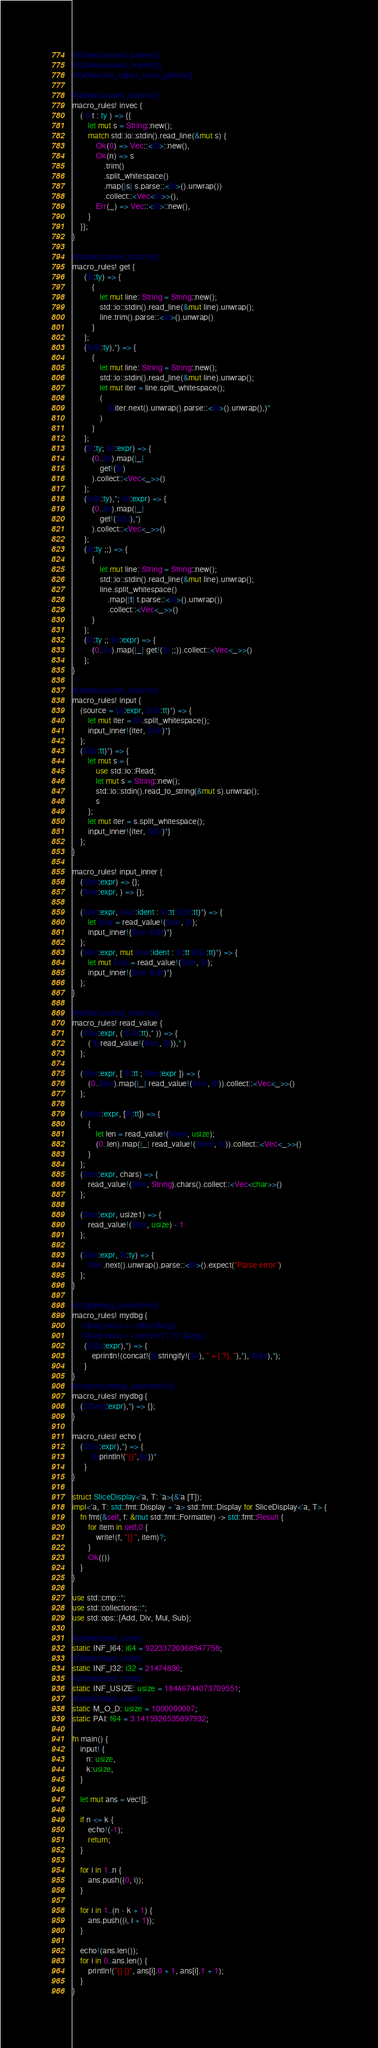Convert code to text. <code><loc_0><loc_0><loc_500><loc_500><_Rust_>#![allow(unused_parens)]
#![allow(unused_imports)]
#![allow(non_upper_case_globals)]

#[allow(unused_macros)]
macro_rules! invec {
    ( $ t : ty ) => {{
        let mut s = String::new();
        match std::io::stdin().read_line(&mut s) {
            Ok(0) => Vec::<$t>::new(),
            Ok(n) => s
                .trim()
                .split_whitespace()
                .map(|s| s.parse::<$t>().unwrap())
                .collect::<Vec<$t>>(),
            Err(_) => Vec::<$t>::new(),
        }
    }};
}

#[allow(unused_macros)]
macro_rules! get {
      ($t:ty) => {
          {
              let mut line: String = String::new();
              std::io::stdin().read_line(&mut line).unwrap();
              line.trim().parse::<$t>().unwrap()
          }
      };
      ($($t:ty),*) => {
          {
              let mut line: String = String::new();
              std::io::stdin().read_line(&mut line).unwrap();
              let mut iter = line.split_whitespace();
              (
                  $(iter.next().unwrap().parse::<$t>().unwrap(),)*
              )
          }
      };
      ($t:ty; $n:expr) => {
          (0..$n).map(|_|
              get!($t)
          ).collect::<Vec<_>>()
      };
      ($($t:ty),*; $n:expr) => {
          (0..$n).map(|_|
              get!($($t),*)
          ).collect::<Vec<_>>()
      };
      ($t:ty ;;) => {
          {
              let mut line: String = String::new();
              std::io::stdin().read_line(&mut line).unwrap();
              line.split_whitespace()
                  .map(|t| t.parse::<$t>().unwrap())
                  .collect::<Vec<_>>()
          }
      };
      ($t:ty ;; $n:expr) => {
          (0..$n).map(|_| get!($t ;;)).collect::<Vec<_>>()
      };
}

#[allow(unused_macros)]
macro_rules! input {
    (source = $s:expr, $($r:tt)*) => {
        let mut iter = $s.split_whitespace();
        input_inner!{iter, $($r)*}
    };
    ($($r:tt)*) => {
        let mut s = {
            use std::io::Read;
            let mut s = String::new();
            std::io::stdin().read_to_string(&mut s).unwrap();
            s
        };
        let mut iter = s.split_whitespace();
        input_inner!{iter, $($r)*}
    };
}

macro_rules! input_inner {
    ($iter:expr) => {};
    ($iter:expr, ) => {};

    ($iter:expr, $var:ident : $t:tt $($r:tt)*) => {
        let $var = read_value!($iter, $t);
        input_inner!{$iter $($r)*}
    };
    ($iter:expr, mut $var:ident : $t:tt $($r:tt)*) => {
        let mut $var = read_value!($iter, $t);
        input_inner!{$iter $($r)*}
    };
}

#[allow(unused_macros)]
macro_rules! read_value {
    ($iter:expr, ( $($t:tt),* )) => {
        ( $(read_value!($iter, $t)),* )
    };

    ($iter:expr, [ $t:tt ; $len:expr ]) => {
        (0..$len).map(|_| read_value!($iter, $t)).collect::<Vec<_>>()
    };

    ($next:expr, [$t:tt]) => {
        {
            let len = read_value!($next, usize);
            (0..len).map(|_| read_value!($next, $t)).collect::<Vec<_>>()
        }
    };
    ($iter:expr, chars) => {
        read_value!($iter, String).chars().collect::<Vec<char>>()
    };

    ($iter:expr, usize1) => {
        read_value!($iter, usize) - 1
    };

    ($iter:expr, $t:ty) => {
        $iter.next().unwrap().parse::<$t>().expect("Parse error")
    };
}

#[cfg(debug_assertions)]
macro_rules! mydbg {
    //($arg:expr) => (dbg!($arg))
    //($arg:expr) => (println!("{:?}",$arg));
      ($($a:expr),*) => {
          eprintln!(concat!($(stringify!($a), " = {:?}, "),*), $($a),*);
      }
}
#[cfg(not(debug_assertions))]
macro_rules! mydbg {
    ($($arg:expr),*) => {};
}

macro_rules! echo {
    ($($a:expr),*) => {
          $(println!("{}",$a))*
      }
}

struct SliceDisplay<'a, T: 'a>(&'a [T]);
impl<'a, T: std::fmt::Display + 'a> std::fmt::Display for SliceDisplay<'a, T> {
    fn fmt(&self, f: &mut std::fmt::Formatter) -> std::fmt::Result {
        for item in self.0 {
            write!(f, "{} ", item)?;
        }
        Ok(())
    }
}

use std::cmp::*;
use std::collections::*;
use std::ops::{Add, Div, Mul, Sub};

#[allow(dead_code)]
static INF_I64: i64 = 92233720368547758;
#[allow(dead_code)]
static INF_I32: i32 = 21474836;
#[allow(dead_code)]
static INF_USIZE: usize = 18446744073709551;
#[allow(dead_code)]
static M_O_D: usize = 1000000007;
static PAI: f64 = 3.1415926535897932;

fn main() {
    input! {
       n: usize,
       k:usize,
    }

    let mut ans = vec![];

    if n <= k {
        echo!(-1);
        return;
    }

    for i in 1..n {
        ans.push((0, i));
    }

    for i in 1..(n - k + 1) {
        ans.push((i, i + 1));
    }

    echo!(ans.len());
    for i in 0..ans.len() {
        println!("{} {}", ans[i].0 + 1, ans[i].1 + 1);
    }
}
</code> 